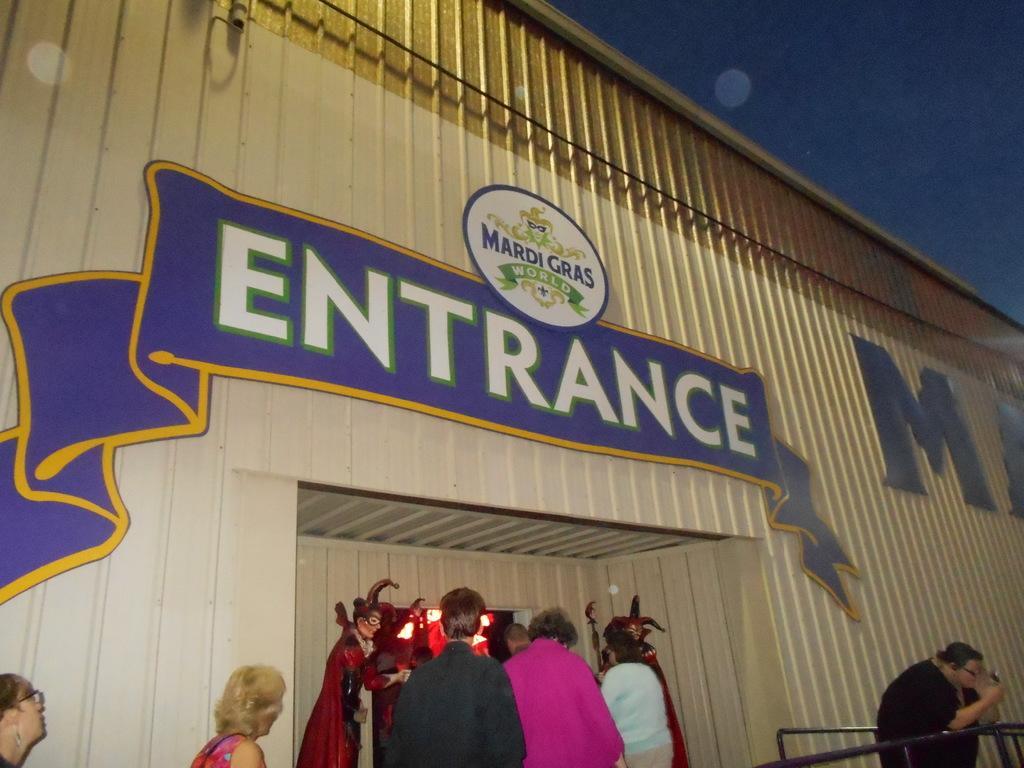Provide a one-sentence caption for the provided image. The entrance to Mardi Gras World has five people waiting in line. 